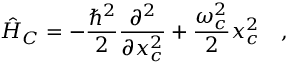<formula> <loc_0><loc_0><loc_500><loc_500>\hat { H } _ { C } = - \frac { \hbar { ^ } { 2 } } { 2 } \frac { \partial ^ { 2 } } { \partial x _ { c } ^ { 2 } } + \frac { \omega _ { c } ^ { 2 } } { 2 } x _ { c } ^ { 2 } \quad ,</formula> 